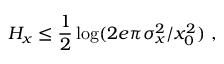<formula> <loc_0><loc_0><loc_500><loc_500>H _ { x } \leq { \frac { 1 } { 2 } } \log ( 2 e \pi \sigma _ { x } ^ { 2 } / x _ { 0 } ^ { 2 } ) ,</formula> 